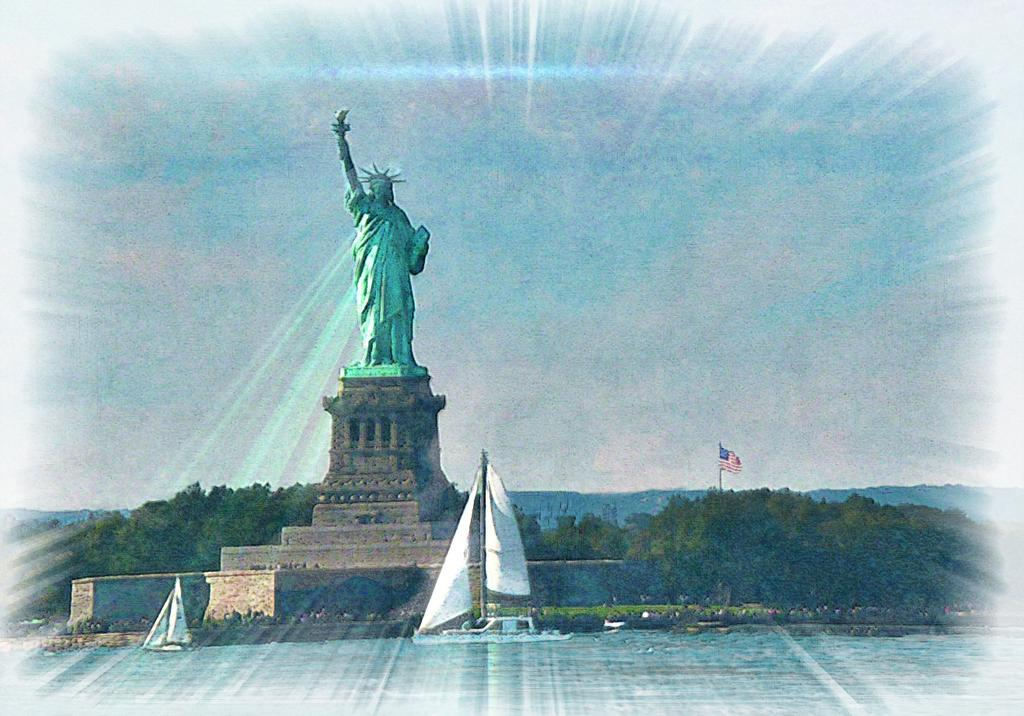What is the main subject of the photograph in the image? There is a photograph of the Liberty Statue in the image. What can be seen in the foreground of the image? There is water visible in the foreground of the image. What type of natural scenery is present in the background of the image? There are trees in the background of the image. What else can be seen in the background of the image? There is a flag on a pole and the sky visible in the background of the image. How does the Liberty Statue feel about experiencing shame in the image? The Liberty Statue is a statue and does not have feelings or experience emotions like shame. 